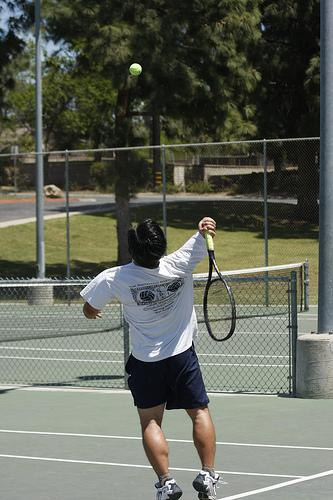Question: where was the photo taken?
Choices:
A. Tennis court.
B. In the yard.
C. At the game.
D. On the ball field.
Answer with the letter. Answer: A Question: what is the person doing?
Choices:
A. Playing basketball.
B. Playing golf.
C. Playing cricket.
D. Playing tennis.
Answer with the letter. Answer: D Question: what does the person have in his hand?
Choices:
A. Baseball bat.
B. Tennis racket.
C. Cricket bat.
D. Golf club.
Answer with the letter. Answer: B Question: what color are the person's shorts?
Choices:
A. Blue.
B. White.
C. Black.
D. Grey.
Answer with the letter. Answer: A Question: how many of the person's heels are touching the ground?
Choices:
A. One.
B. Two.
C. Three.
D. None.
Answer with the letter. Answer: D 